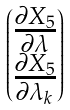<formula> <loc_0><loc_0><loc_500><loc_500>\begin{pmatrix} \frac { \partial X _ { 5 } } { \partial \lambda } \\ \frac { \partial X _ { 5 } } { \partial \lambda _ { k } } \end{pmatrix}</formula> 